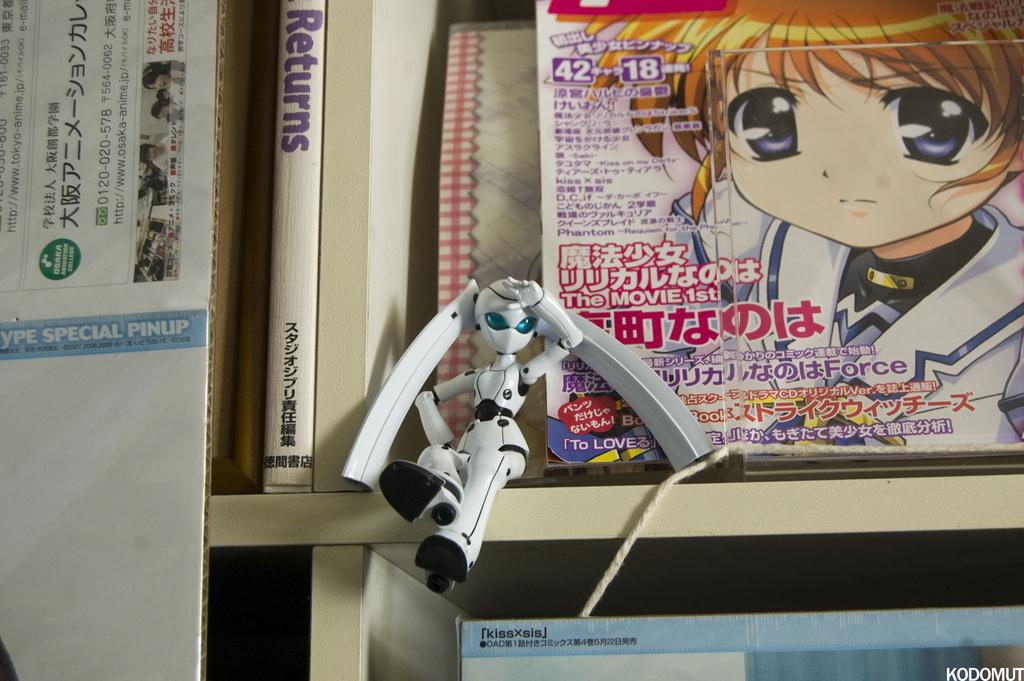<image>
Share a concise interpretation of the image provided. A small toy in front of a magazine with an animated character on the cover, which says Phantom and The Movie First. 